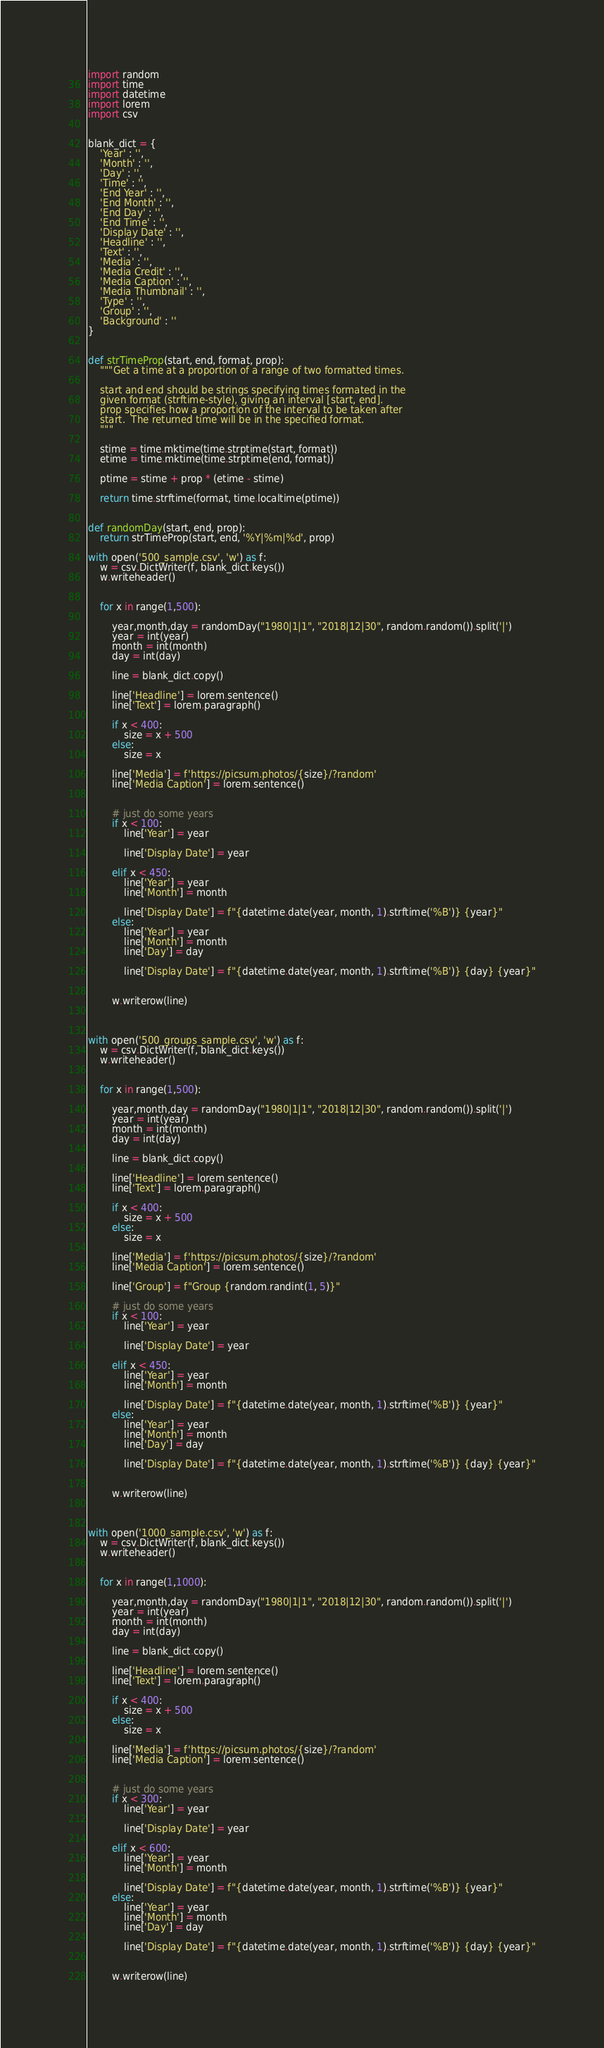Convert code to text. <code><loc_0><loc_0><loc_500><loc_500><_Python_>import random
import time
import datetime
import lorem
import csv


blank_dict = {
    'Year' : '',
    'Month' : '',
    'Day' : '',
    'Time' : '',
    'End Year' : '',
    'End Month' : '',
    'End Day' : '',
    'End Time' : '',
    'Display Date' : '',
    'Headline' : '',
    'Text' : '',
    'Media' : '',
    'Media Credit' : '',
    'Media Caption' : '',
    'Media Thumbnail' : '',
    'Type' : '',
    'Group' : '',
    'Background' : ''
}


def strTimeProp(start, end, format, prop):
    """Get a time at a proportion of a range of two formatted times.

    start and end should be strings specifying times formated in the
    given format (strftime-style), giving an interval [start, end].
    prop specifies how a proportion of the interval to be taken after
    start.  The returned time will be in the specified format.
    """

    stime = time.mktime(time.strptime(start, format))
    etime = time.mktime(time.strptime(end, format))

    ptime = stime + prop * (etime - stime)

    return time.strftime(format, time.localtime(ptime))


def randomDay(start, end, prop):
    return strTimeProp(start, end, '%Y|%m|%d', prop)

with open('500_sample.csv', 'w') as f:
    w = csv.DictWriter(f, blank_dict.keys())
    w.writeheader()
    

    for x in range(1,500):

        year,month,day = randomDay("1980|1|1", "2018|12|30", random.random()).split('|')
        year = int(year)
        month = int(month)
        day = int(day)

        line = blank_dict.copy()

        line['Headline'] = lorem.sentence()
        line['Text'] = lorem.paragraph()

        if x < 400:
            size = x + 500
        else:
            size = x
        
        line['Media'] = f'https://picsum.photos/{size}/?random'
        line['Media Caption'] = lorem.sentence()


        # just do some years
        if x < 100:
            line['Year'] = year

            line['Display Date'] = year

        elif x < 450:
            line['Year'] = year
            line['Month'] = month

            line['Display Date'] = f"{datetime.date(year, month, 1).strftime('%B')} {year}"
        else:
            line['Year'] = year
            line['Month'] = month
            line['Day'] = day

            line['Display Date'] = f"{datetime.date(year, month, 1).strftime('%B')} {day} {year}"
           

        w.writerow(line)



with open('500_groups_sample.csv', 'w') as f:
    w = csv.DictWriter(f, blank_dict.keys())
    w.writeheader()
    

    for x in range(1,500):

        year,month,day = randomDay("1980|1|1", "2018|12|30", random.random()).split('|')
        year = int(year)
        month = int(month)
        day = int(day)

        line = blank_dict.copy()

        line['Headline'] = lorem.sentence()
        line['Text'] = lorem.paragraph()

        if x < 400:
            size = x + 500
        else:
            size = x
        
        line['Media'] = f'https://picsum.photos/{size}/?random'
        line['Media Caption'] = lorem.sentence()

        line['Group'] = f"Group {random.randint(1, 5)}"

        # just do some years
        if x < 100:
            line['Year'] = year

            line['Display Date'] = year

        elif x < 450:
            line['Year'] = year
            line['Month'] = month

            line['Display Date'] = f"{datetime.date(year, month, 1).strftime('%B')} {year}"
        else:
            line['Year'] = year
            line['Month'] = month
            line['Day'] = day

            line['Display Date'] = f"{datetime.date(year, month, 1).strftime('%B')} {day} {year}"
           

        w.writerow(line)



with open('1000_sample.csv', 'w') as f:
    w = csv.DictWriter(f, blank_dict.keys())
    w.writeheader()
    

    for x in range(1,1000):

        year,month,day = randomDay("1980|1|1", "2018|12|30", random.random()).split('|')
        year = int(year)
        month = int(month)
        day = int(day)

        line = blank_dict.copy()

        line['Headline'] = lorem.sentence()
        line['Text'] = lorem.paragraph()

        if x < 400:
            size = x + 500
        else:
            size = x
        
        line['Media'] = f'https://picsum.photos/{size}/?random'
        line['Media Caption'] = lorem.sentence()


        # just do some years
        if x < 300:
            line['Year'] = year

            line['Display Date'] = year

        elif x < 600:
            line['Year'] = year
            line['Month'] = month

            line['Display Date'] = f"{datetime.date(year, month, 1).strftime('%B')} {year}"
        else:
            line['Year'] = year
            line['Month'] = month
            line['Day'] = day

            line['Display Date'] = f"{datetime.date(year, month, 1).strftime('%B')} {day} {year}"
           

        w.writerow(line)



</code> 